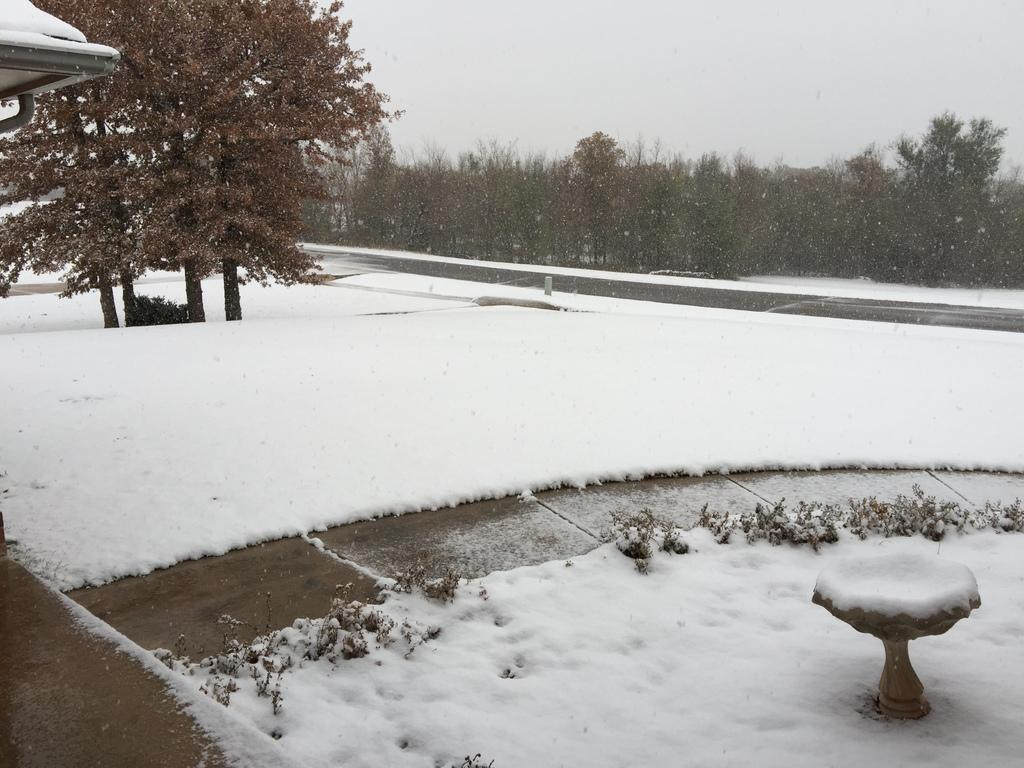What is the main feature of the image? The main feature of the image is a path covered by snow. What else can be seen in the image besides the snowy path? There are plants visible in the image. What is visible in the background of the image? There are trees and the sky visible in the background of the image. What type of skin condition can be seen on the plants in the image? There is no mention of any skin condition on the plants in the image. The plants appear to be healthy and covered in snow. 